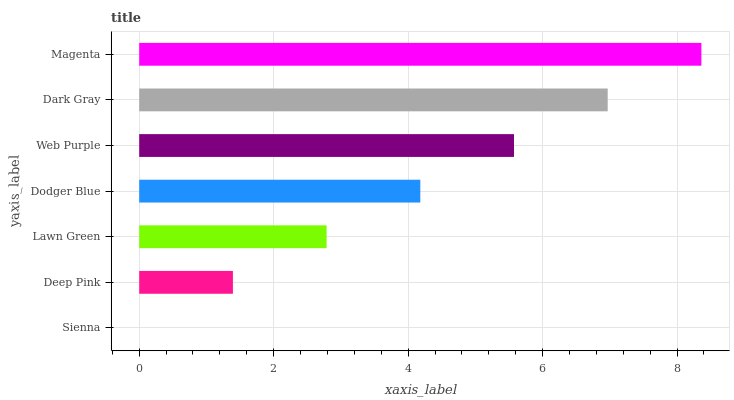Is Sienna the minimum?
Answer yes or no. Yes. Is Magenta the maximum?
Answer yes or no. Yes. Is Deep Pink the minimum?
Answer yes or no. No. Is Deep Pink the maximum?
Answer yes or no. No. Is Deep Pink greater than Sienna?
Answer yes or no. Yes. Is Sienna less than Deep Pink?
Answer yes or no. Yes. Is Sienna greater than Deep Pink?
Answer yes or no. No. Is Deep Pink less than Sienna?
Answer yes or no. No. Is Dodger Blue the high median?
Answer yes or no. Yes. Is Dodger Blue the low median?
Answer yes or no. Yes. Is Web Purple the high median?
Answer yes or no. No. Is Dark Gray the low median?
Answer yes or no. No. 